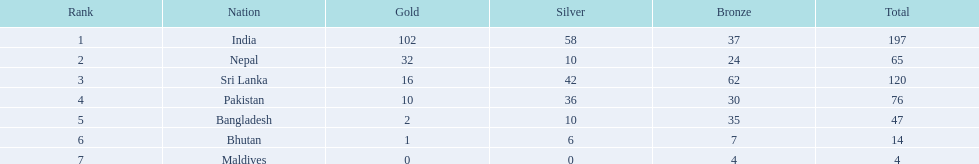What are the aggregate numbers of medals secured in each nation? 197, 65, 120, 76, 47, 14, 4. Which of these numbers are fewer than 10? 4. Who gained this count of medals? Maldives. 